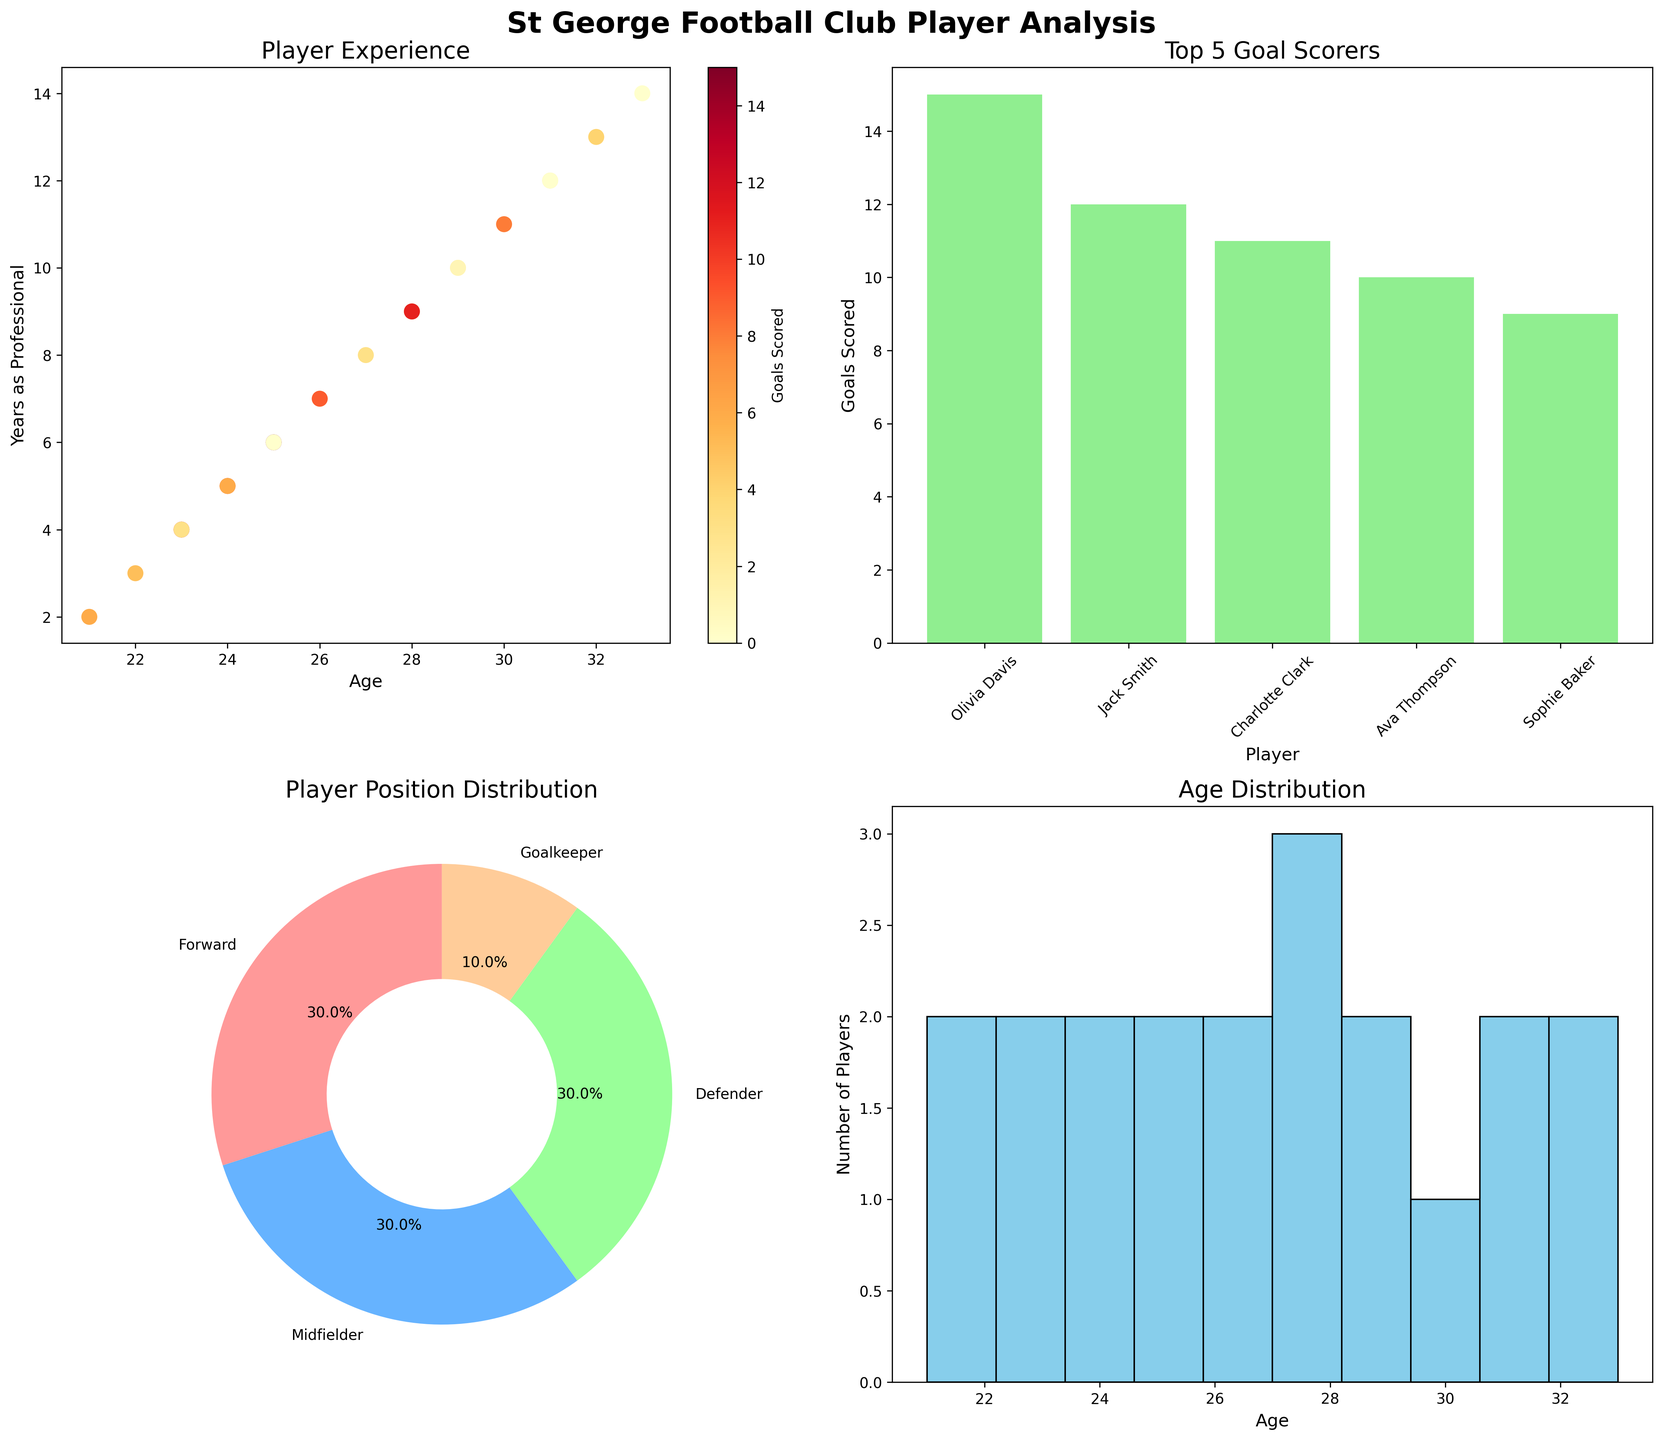What's the age range of the players? Look at the histogram of the age distribution. The minimum age is 21 and the maximum age is 33. So, the age range is 33 - 21.
Answer: 12 years Which player scored the most goals? Refer to the bar plot of the top 5 goal scorers. Olivia Davis has the highest bar with the most goals scored, 15.
Answer: Olivia Davis How many players have more than 10 years of professional experience? Look at the scatter plot where the age is plotted against the years of professional experience. Count the dots above the 10-year mark. There are four players above this threshold.
Answer: 4 players What's the position with the highest number of players? Refer to the pie chart showing the player position distribution. The Midfielder slice is the largest.
Answer: Midfielder Which age group has the most players? Look at the histogram of the age distribution. The bin corresponding to ages 29-30 has the highest bar indicating that this group has the most players.
Answer: 29-30 years How many goals did the top 2 scorers combined score? Look at the bar plot of the top 5 goal scorers. Olivia Davis scored 15 goals and Jack Smith scored 12 goals. Their combined score is 15 + 12.
Answer: 27 goals Which position has the fewest players? Refer to the pie chart showing the player position distribution. The Goalkeeper slice is the smallest, indicating it has the fewest players.
Answer: Goalkeeper Are there more players aged above 30 or below 25? Look at the histogram of the age distribution. Count the players aged above 30 (31, 32, 33) and those below 25 (21, 22, 23, 24). There are five players aged above 30 and five players below 25.
Answer: Equal What's the average number of years of professional experience for the Midfielders? Identify the midfielders from the table and sum up their years of experience (9+3+11+12+13). There are 5 midfielders, so the average years of experience is (9+3+11+12+13) / 5.
Answer: 9.6 years 